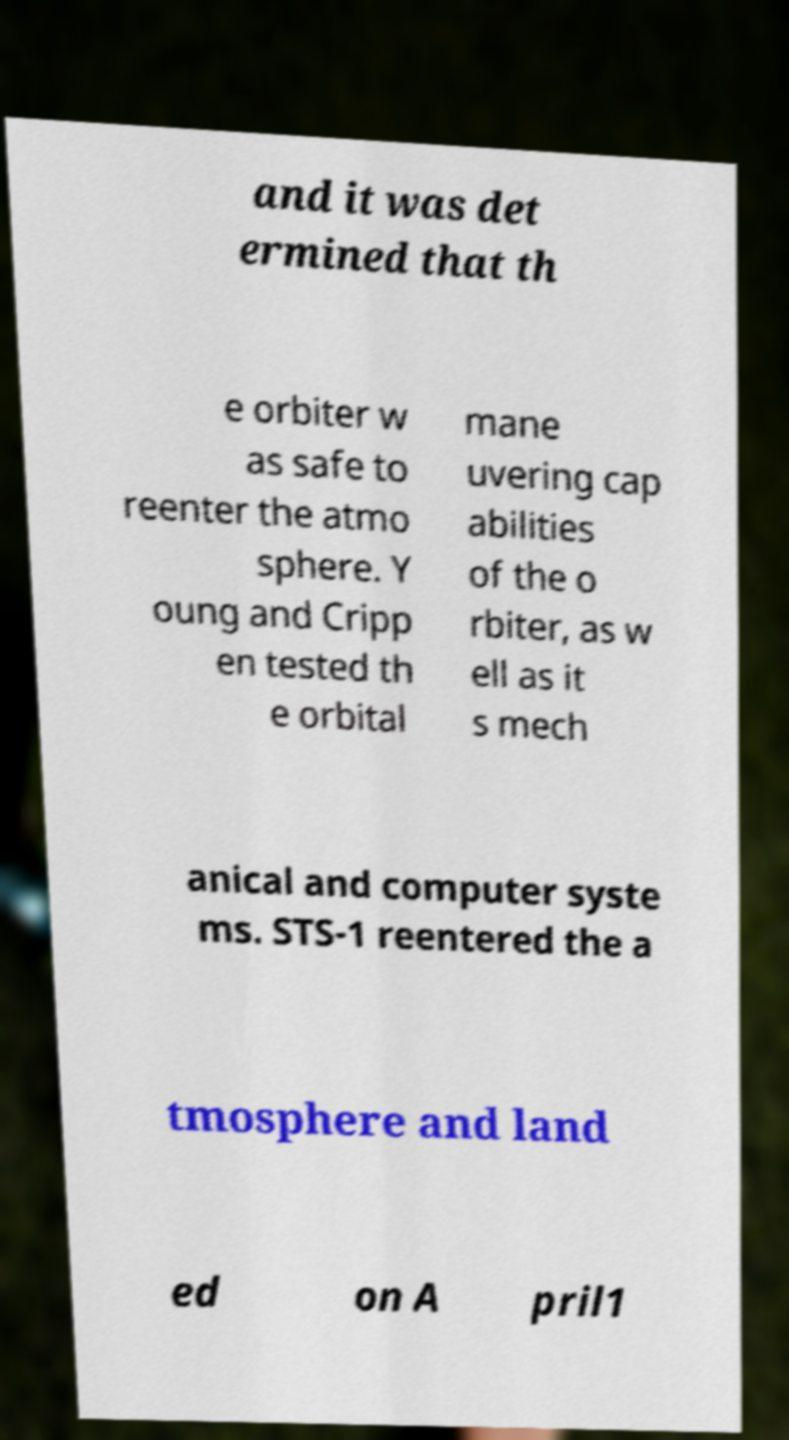Can you accurately transcribe the text from the provided image for me? and it was det ermined that th e orbiter w as safe to reenter the atmo sphere. Y oung and Cripp en tested th e orbital mane uvering cap abilities of the o rbiter, as w ell as it s mech anical and computer syste ms. STS-1 reentered the a tmosphere and land ed on A pril1 